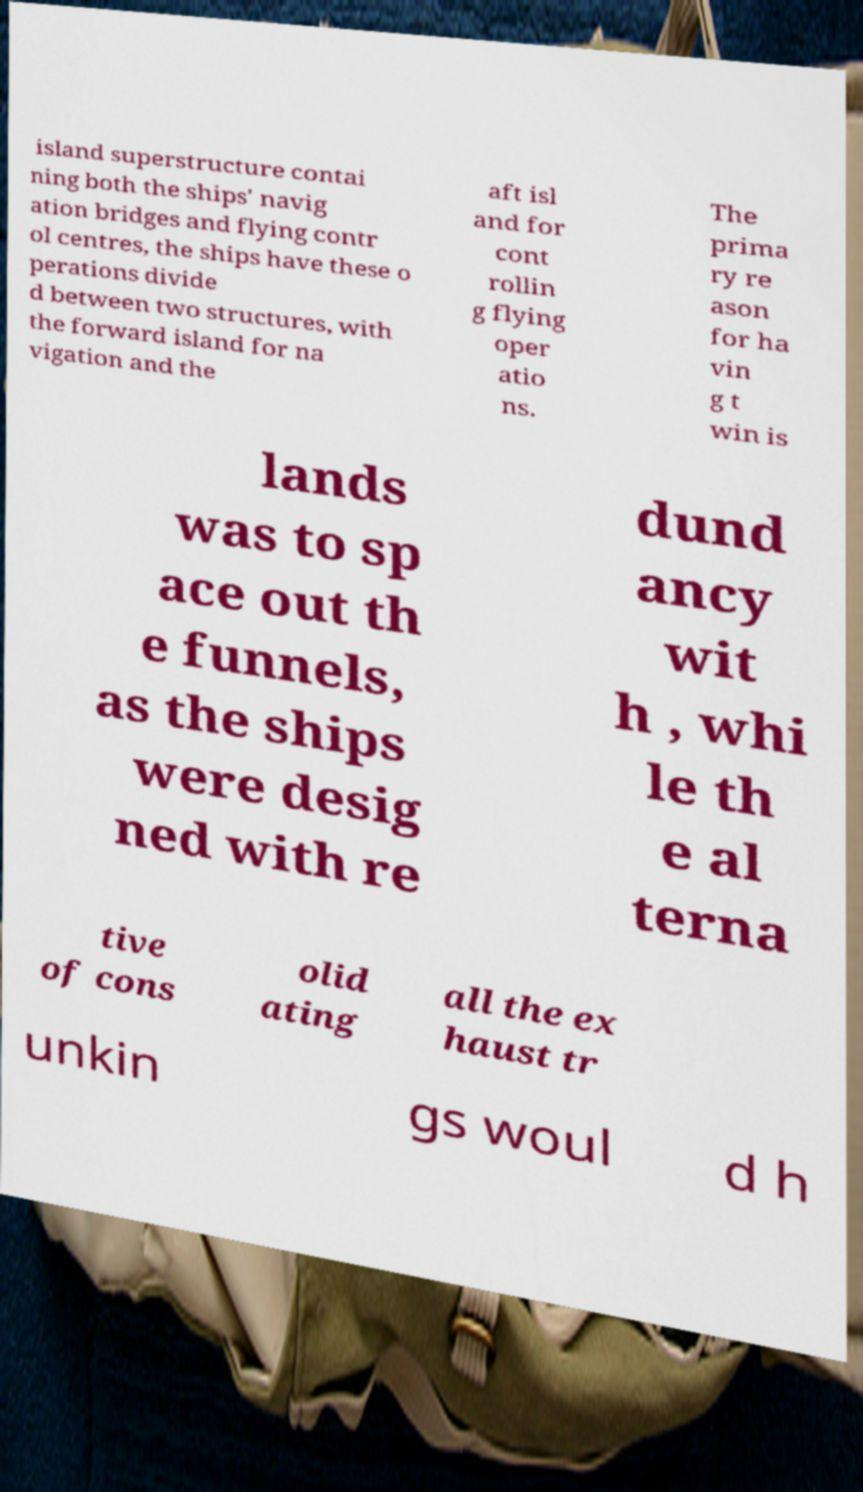Could you extract and type out the text from this image? island superstructure contai ning both the ships' navig ation bridges and flying contr ol centres, the ships have these o perations divide d between two structures, with the forward island for na vigation and the aft isl and for cont rollin g flying oper atio ns. The prima ry re ason for ha vin g t win is lands was to sp ace out th e funnels, as the ships were desig ned with re dund ancy wit h , whi le th e al terna tive of cons olid ating all the ex haust tr unkin gs woul d h 